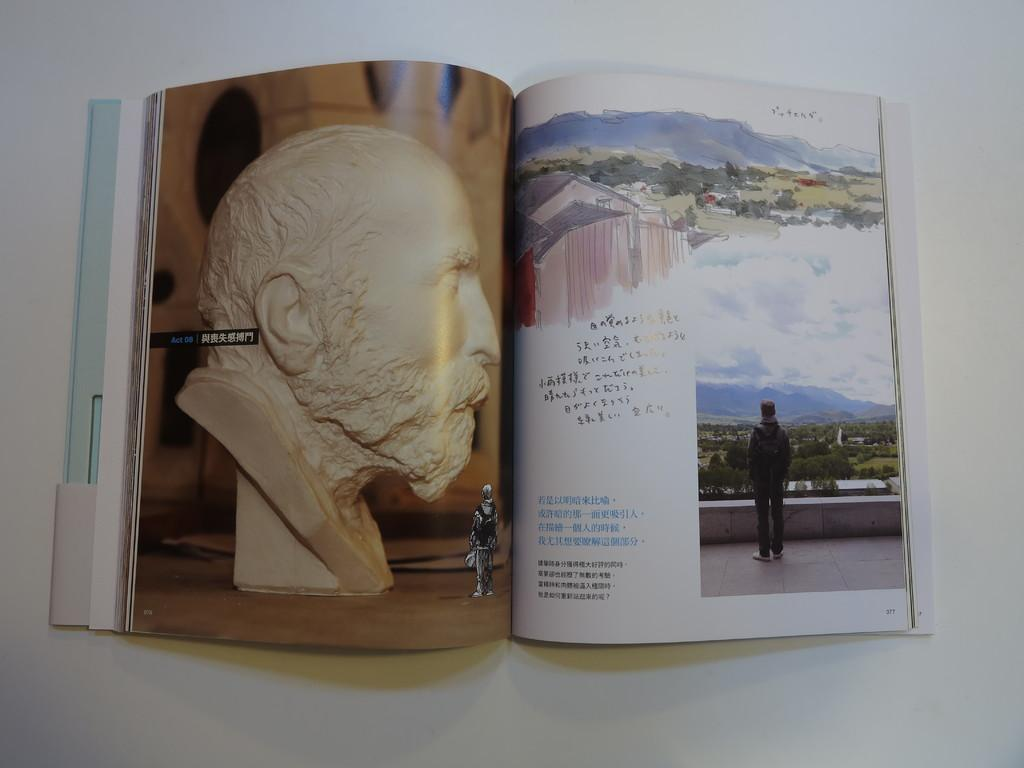<image>
Create a compact narrative representing the image presented. The book in Japanese language is opened to page 377. 